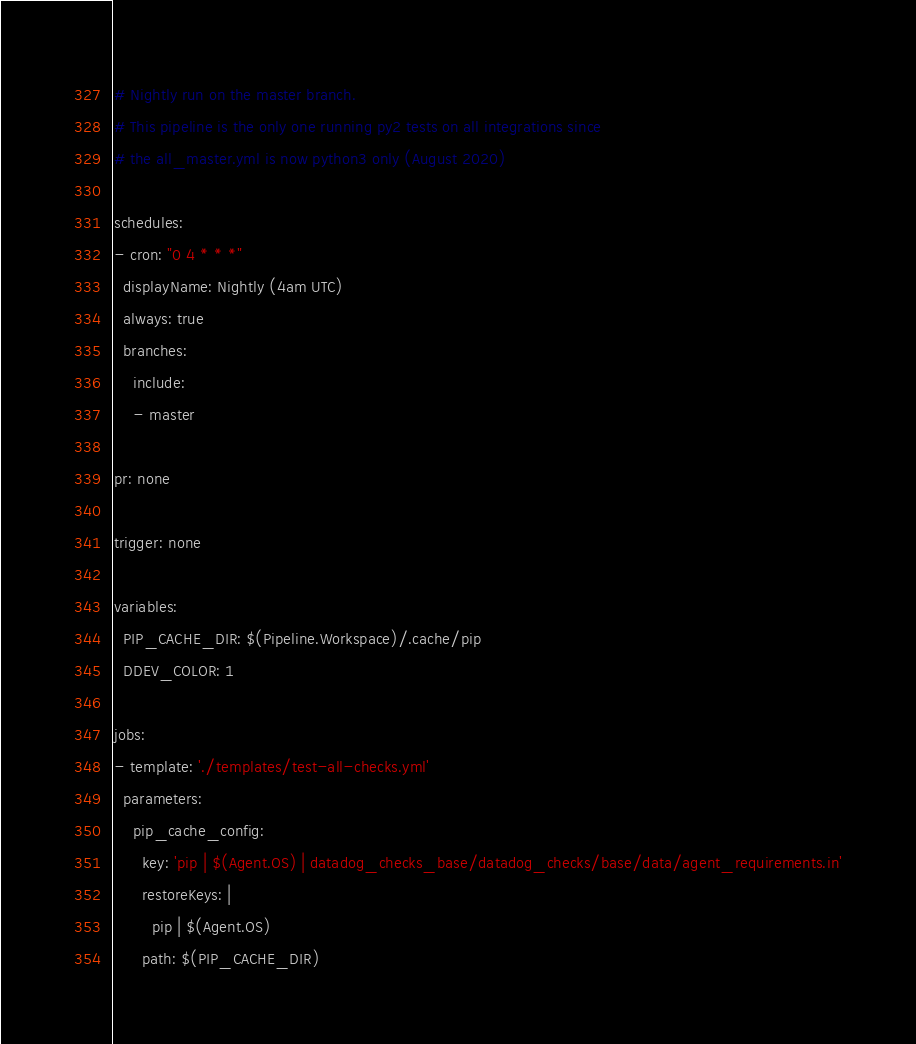<code> <loc_0><loc_0><loc_500><loc_500><_YAML_># Nightly run on the master branch.
# This pipeline is the only one running py2 tests on all integrations since
# the all_master.yml is now python3 only (August 2020)

schedules:
- cron: "0 4 * * *"
  displayName: Nightly (4am UTC)
  always: true
  branches:
    include:
    - master

pr: none

trigger: none

variables:
  PIP_CACHE_DIR: $(Pipeline.Workspace)/.cache/pip
  DDEV_COLOR: 1

jobs:
- template: './templates/test-all-checks.yml'
  parameters:
    pip_cache_config:
      key: 'pip | $(Agent.OS) | datadog_checks_base/datadog_checks/base/data/agent_requirements.in'
      restoreKeys: |
        pip | $(Agent.OS)
      path: $(PIP_CACHE_DIR)
</code> 